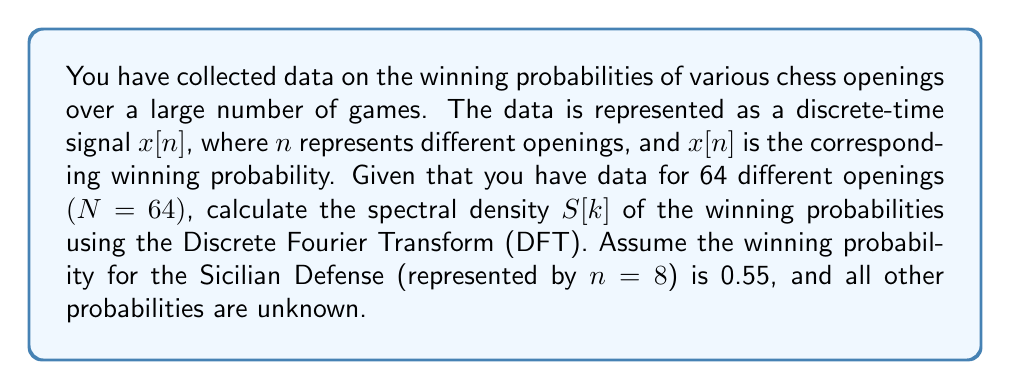Show me your answer to this math problem. To solve this problem, we need to follow these steps:

1) The Discrete Fourier Transform (DFT) of a signal $x[n]$ is given by:

   $$X[k] = \sum_{n=0}^{N-1} x[n] e^{-j2\pi kn/N}$$

   where $k = 0, 1, ..., N-1$

2) The spectral density $S[k]$ is defined as the magnitude squared of the DFT:

   $$S[k] = |X[k]|^2$$

3) In this case, we only know one value of $x[n]$, which is $x[8] = 0.55$ (Sicilian Defense). All other values are unknown.

4) Substituting the known value into the DFT equation:

   $$X[k] = 0.55 e^{-j2\pi k(8)/64} + \sum_{n \neq 8} x[n] e^{-j2\pi kn/64}$$

5) The second term is unknown, so we can't calculate the exact $X[k]$. However, we can calculate the contribution of the known term to $X[k]$:

   $$X_{known}[k] = 0.55 e^{-j2\pi k(8)/64} = 0.55 e^{-j\pi k/4}$$

6) The spectral density contribution from this known term is:

   $$S_{known}[k] = |X_{known}[k]|^2 = |0.55 e^{-j\pi k/4}|^2 = 0.55^2 = 0.3025$$

7) This value is constant for all $k$ because the magnitude of a complex exponential is always 1.

Therefore, while we can't calculate the full spectral density without knowing all the $x[n]$ values, we can say that the Sicilian Defense contributes a constant value of 0.3025 to the spectral density for all frequencies $k$.
Answer: The contribution of the Sicilian Defense to the spectral density $S[k]$ is 0.3025 for all $k$. 